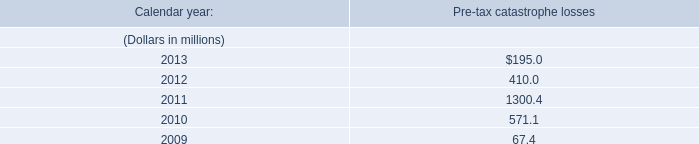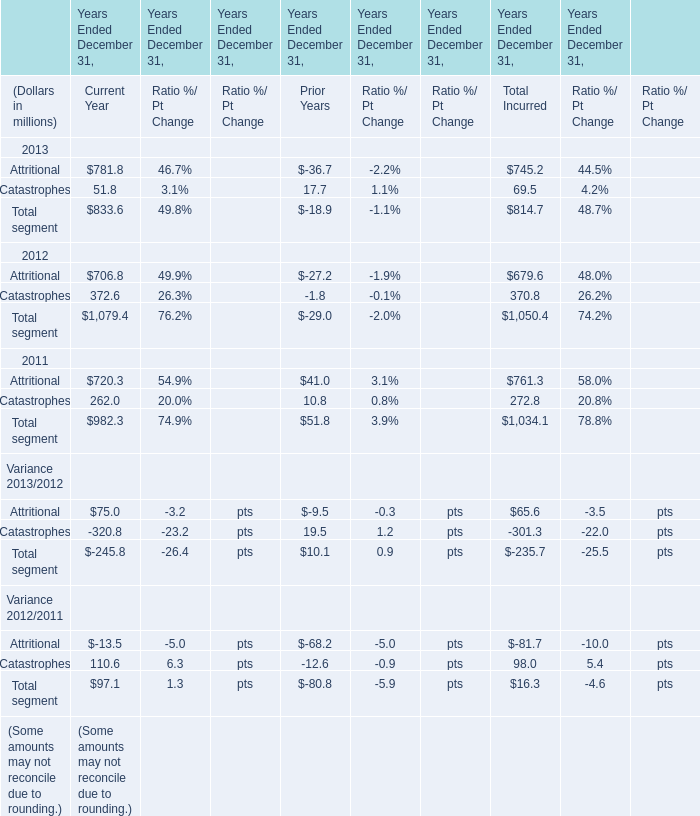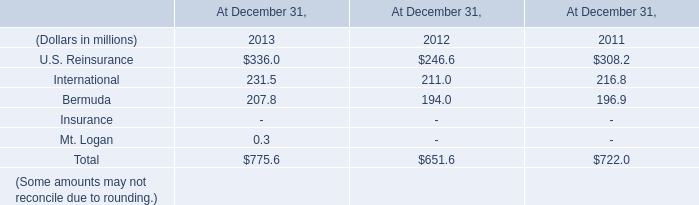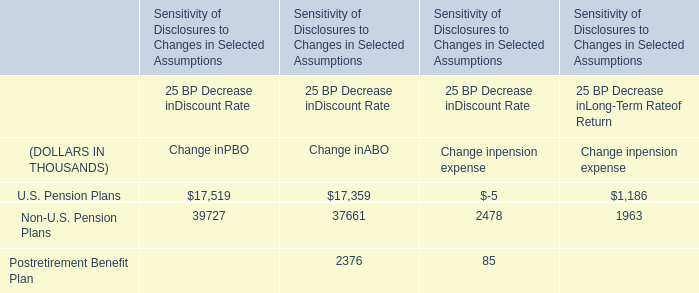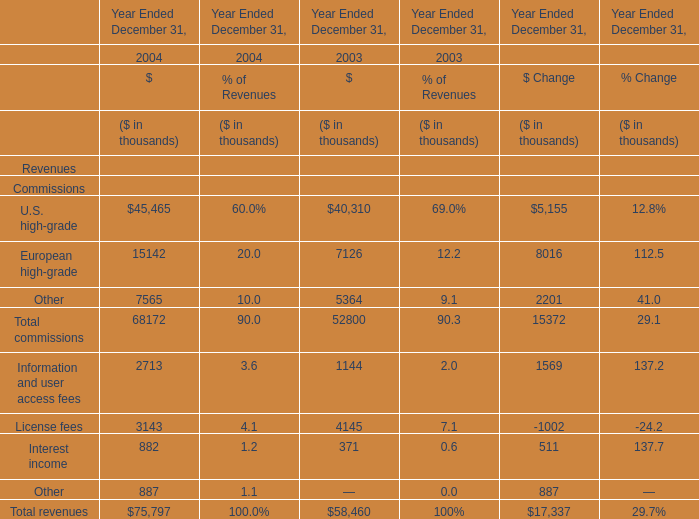In the year with largest amount of Other, what's the sum of revenues? (in thousand) 
Computations: ((((((45465 + 15142) + 7565) + 2713) + 3143) + 882) + 887)
Answer: 75797.0. 